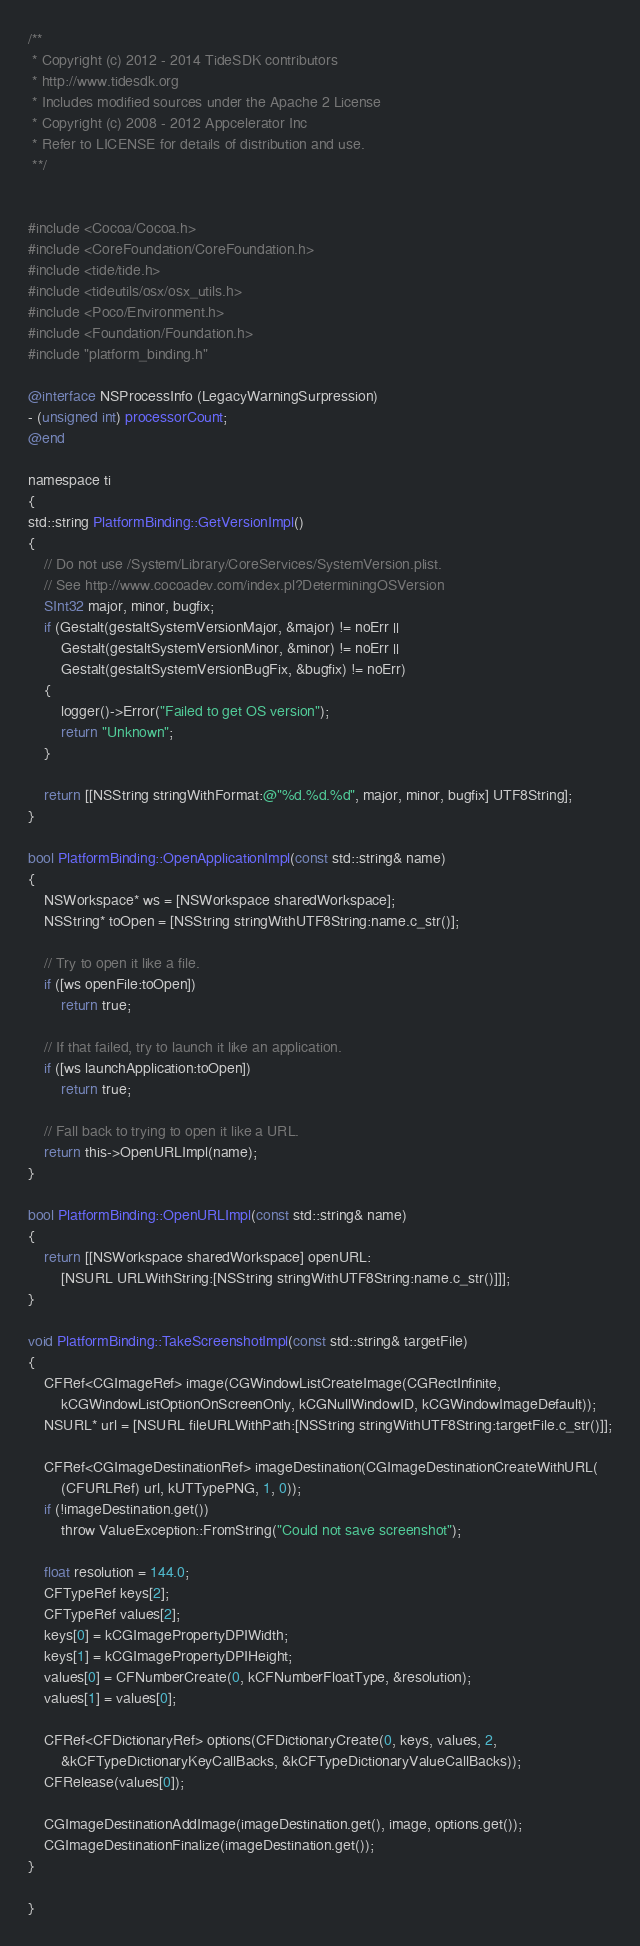Convert code to text. <code><loc_0><loc_0><loc_500><loc_500><_ObjectiveC_>/**
 * Copyright (c) 2012 - 2014 TideSDK contributors
 * http://www.tidesdk.org
 * Includes modified sources under the Apache 2 License
 * Copyright (c) 2008 - 2012 Appcelerator Inc
 * Refer to LICENSE for details of distribution and use.
 **/


#include <Cocoa/Cocoa.h>
#include <CoreFoundation/CoreFoundation.h>
#include <tide/tide.h>
#include <tideutils/osx/osx_utils.h>
#include <Poco/Environment.h>
#include <Foundation/Foundation.h>
#include "platform_binding.h"

@interface NSProcessInfo (LegacyWarningSurpression)
- (unsigned int) processorCount;
@end

namespace ti
{
std::string PlatformBinding::GetVersionImpl()
{
    // Do not use /System/Library/CoreServices/SystemVersion.plist.
    // See http://www.cocoadev.com/index.pl?DeterminingOSVersion
    SInt32 major, minor, bugfix;
    if (Gestalt(gestaltSystemVersionMajor, &major) != noErr ||
        Gestalt(gestaltSystemVersionMinor, &minor) != noErr ||
        Gestalt(gestaltSystemVersionBugFix, &bugfix) != noErr)
    {
        logger()->Error("Failed to get OS version");
        return "Unknown";
    }

    return [[NSString stringWithFormat:@"%d.%d.%d", major, minor, bugfix] UTF8String];
}

bool PlatformBinding::OpenApplicationImpl(const std::string& name)
{
    NSWorkspace* ws = [NSWorkspace sharedWorkspace];
    NSString* toOpen = [NSString stringWithUTF8String:name.c_str()];

    // Try to open it like a file.
    if ([ws openFile:toOpen])
        return true;

    // If that failed, try to launch it like an application.
    if ([ws launchApplication:toOpen])
        return true;

    // Fall back to trying to open it like a URL.
    return this->OpenURLImpl(name);
}

bool PlatformBinding::OpenURLImpl(const std::string& name)
{
    return [[NSWorkspace sharedWorkspace] openURL:
        [NSURL URLWithString:[NSString stringWithUTF8String:name.c_str()]]];
}

void PlatformBinding::TakeScreenshotImpl(const std::string& targetFile)
{
    CFRef<CGImageRef> image(CGWindowListCreateImage(CGRectInfinite,
        kCGWindowListOptionOnScreenOnly, kCGNullWindowID, kCGWindowImageDefault));
    NSURL* url = [NSURL fileURLWithPath:[NSString stringWithUTF8String:targetFile.c_str()]];

    CFRef<CGImageDestinationRef> imageDestination(CGImageDestinationCreateWithURL(
        (CFURLRef) url, kUTTypePNG, 1, 0));
    if (!imageDestination.get())
        throw ValueException::FromString("Could not save screenshot");

    float resolution = 144.0;
    CFTypeRef keys[2];
    CFTypeRef values[2];
    keys[0] = kCGImagePropertyDPIWidth;
    keys[1] = kCGImagePropertyDPIHeight;
    values[0] = CFNumberCreate(0, kCFNumberFloatType, &resolution);
    values[1] = values[0];

    CFRef<CFDictionaryRef> options(CFDictionaryCreate(0, keys, values, 2,
        &kCFTypeDictionaryKeyCallBacks, &kCFTypeDictionaryValueCallBacks));
    CFRelease(values[0]);

    CGImageDestinationAddImage(imageDestination.get(), image, options.get());
    CGImageDestinationFinalize(imageDestination.get());
}

}
</code> 